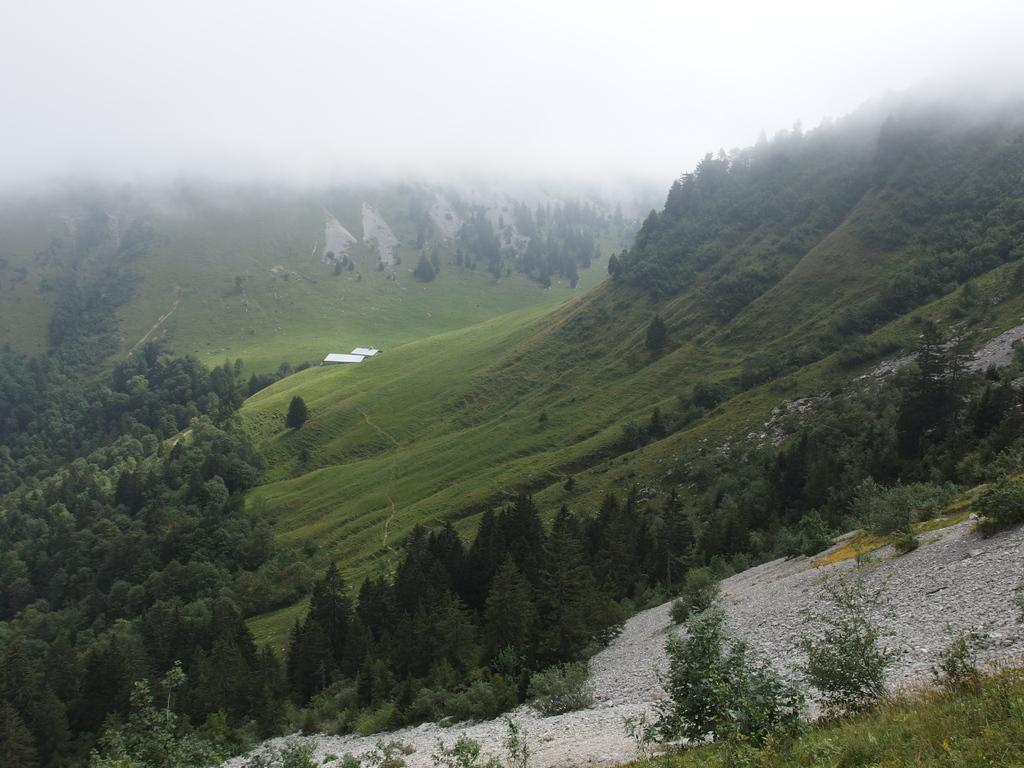What type of vegetation can be seen in the image? There are trees and plants in the image. Can you describe the landscape in the image? The image features hills visible in the background. What type of glue is used to hold the scene together in the image? There is no glue present in the image, as it is a photograph or digital representation of a real-life scene. 